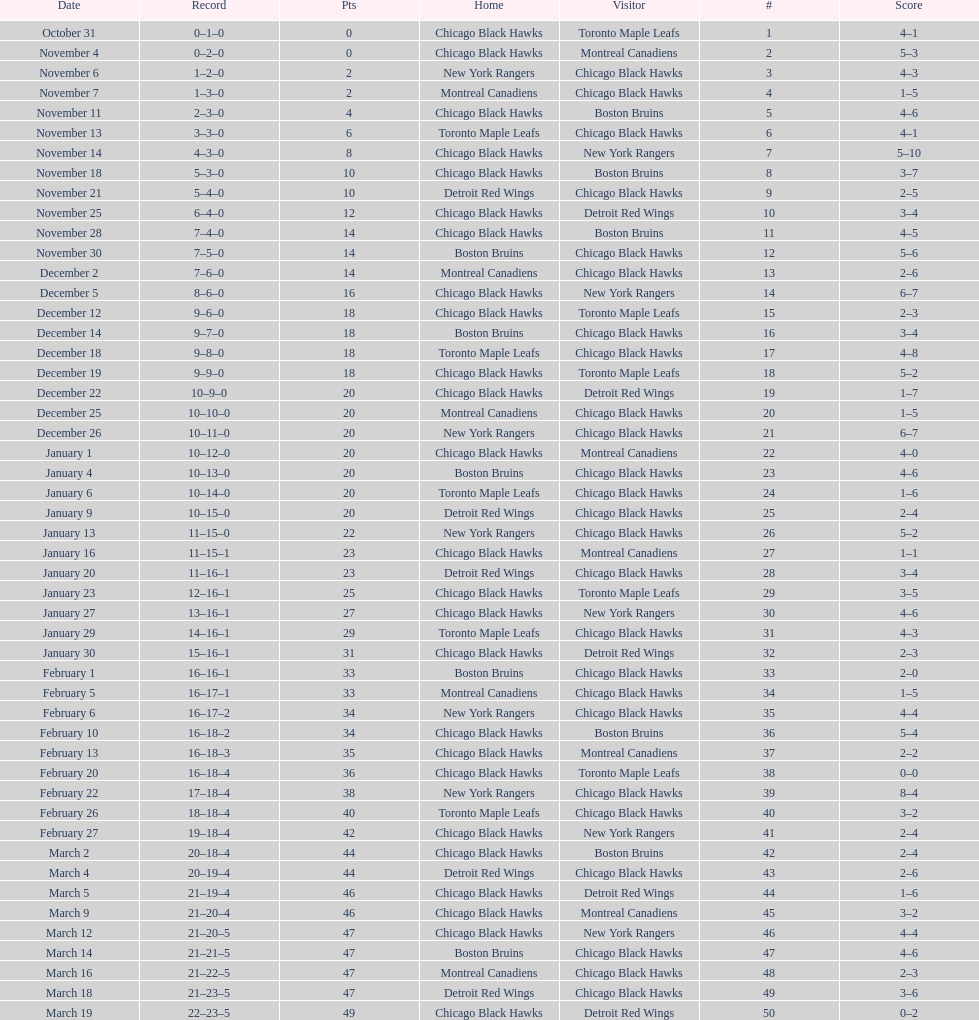How long is the duration of one season (from the first game to the last)? 5 months. Would you mind parsing the complete table? {'header': ['Date', 'Record', 'Pts', 'Home', 'Visitor', '#', 'Score'], 'rows': [['October 31', '0–1–0', '0', 'Chicago Black Hawks', 'Toronto Maple Leafs', '1', '4–1'], ['November 4', '0–2–0', '0', 'Chicago Black Hawks', 'Montreal Canadiens', '2', '5–3'], ['November 6', '1–2–0', '2', 'New York Rangers', 'Chicago Black Hawks', '3', '4–3'], ['November 7', '1–3–0', '2', 'Montreal Canadiens', 'Chicago Black Hawks', '4', '1–5'], ['November 11', '2–3–0', '4', 'Chicago Black Hawks', 'Boston Bruins', '5', '4–6'], ['November 13', '3–3–0', '6', 'Toronto Maple Leafs', 'Chicago Black Hawks', '6', '4–1'], ['November 14', '4–3–0', '8', 'Chicago Black Hawks', 'New York Rangers', '7', '5–10'], ['November 18', '5–3–0', '10', 'Chicago Black Hawks', 'Boston Bruins', '8', '3–7'], ['November 21', '5–4–0', '10', 'Detroit Red Wings', 'Chicago Black Hawks', '9', '2–5'], ['November 25', '6–4–0', '12', 'Chicago Black Hawks', 'Detroit Red Wings', '10', '3–4'], ['November 28', '7–4–0', '14', 'Chicago Black Hawks', 'Boston Bruins', '11', '4–5'], ['November 30', '7–5–0', '14', 'Boston Bruins', 'Chicago Black Hawks', '12', '5–6'], ['December 2', '7–6–0', '14', 'Montreal Canadiens', 'Chicago Black Hawks', '13', '2–6'], ['December 5', '8–6–0', '16', 'Chicago Black Hawks', 'New York Rangers', '14', '6–7'], ['December 12', '9–6–0', '18', 'Chicago Black Hawks', 'Toronto Maple Leafs', '15', '2–3'], ['December 14', '9–7–0', '18', 'Boston Bruins', 'Chicago Black Hawks', '16', '3–4'], ['December 18', '9–8–0', '18', 'Toronto Maple Leafs', 'Chicago Black Hawks', '17', '4–8'], ['December 19', '9–9–0', '18', 'Chicago Black Hawks', 'Toronto Maple Leafs', '18', '5–2'], ['December 22', '10–9–0', '20', 'Chicago Black Hawks', 'Detroit Red Wings', '19', '1–7'], ['December 25', '10–10–0', '20', 'Montreal Canadiens', 'Chicago Black Hawks', '20', '1–5'], ['December 26', '10–11–0', '20', 'New York Rangers', 'Chicago Black Hawks', '21', '6–7'], ['January 1', '10–12–0', '20', 'Chicago Black Hawks', 'Montreal Canadiens', '22', '4–0'], ['January 4', '10–13–0', '20', 'Boston Bruins', 'Chicago Black Hawks', '23', '4–6'], ['January 6', '10–14–0', '20', 'Toronto Maple Leafs', 'Chicago Black Hawks', '24', '1–6'], ['January 9', '10–15–0', '20', 'Detroit Red Wings', 'Chicago Black Hawks', '25', '2–4'], ['January 13', '11–15–0', '22', 'New York Rangers', 'Chicago Black Hawks', '26', '5–2'], ['January 16', '11–15–1', '23', 'Chicago Black Hawks', 'Montreal Canadiens', '27', '1–1'], ['January 20', '11–16–1', '23', 'Detroit Red Wings', 'Chicago Black Hawks', '28', '3–4'], ['January 23', '12–16–1', '25', 'Chicago Black Hawks', 'Toronto Maple Leafs', '29', '3–5'], ['January 27', '13–16–1', '27', 'Chicago Black Hawks', 'New York Rangers', '30', '4–6'], ['January 29', '14–16–1', '29', 'Toronto Maple Leafs', 'Chicago Black Hawks', '31', '4–3'], ['January 30', '15–16–1', '31', 'Chicago Black Hawks', 'Detroit Red Wings', '32', '2–3'], ['February 1', '16–16–1', '33', 'Boston Bruins', 'Chicago Black Hawks', '33', '2–0'], ['February 5', '16–17–1', '33', 'Montreal Canadiens', 'Chicago Black Hawks', '34', '1–5'], ['February 6', '16–17–2', '34', 'New York Rangers', 'Chicago Black Hawks', '35', '4–4'], ['February 10', '16–18–2', '34', 'Chicago Black Hawks', 'Boston Bruins', '36', '5–4'], ['February 13', '16–18–3', '35', 'Chicago Black Hawks', 'Montreal Canadiens', '37', '2–2'], ['February 20', '16–18–4', '36', 'Chicago Black Hawks', 'Toronto Maple Leafs', '38', '0–0'], ['February 22', '17–18–4', '38', 'New York Rangers', 'Chicago Black Hawks', '39', '8–4'], ['February 26', '18–18–4', '40', 'Toronto Maple Leafs', 'Chicago Black Hawks', '40', '3–2'], ['February 27', '19–18–4', '42', 'Chicago Black Hawks', 'New York Rangers', '41', '2–4'], ['March 2', '20–18–4', '44', 'Chicago Black Hawks', 'Boston Bruins', '42', '2–4'], ['March 4', '20–19–4', '44', 'Detroit Red Wings', 'Chicago Black Hawks', '43', '2–6'], ['March 5', '21–19–4', '46', 'Chicago Black Hawks', 'Detroit Red Wings', '44', '1–6'], ['March 9', '21–20–4', '46', 'Chicago Black Hawks', 'Montreal Canadiens', '45', '3–2'], ['March 12', '21–20–5', '47', 'Chicago Black Hawks', 'New York Rangers', '46', '4–4'], ['March 14', '21–21–5', '47', 'Boston Bruins', 'Chicago Black Hawks', '47', '4–6'], ['March 16', '21–22–5', '47', 'Montreal Canadiens', 'Chicago Black Hawks', '48', '2–3'], ['March 18', '21–23–5', '47', 'Detroit Red Wings', 'Chicago Black Hawks', '49', '3–6'], ['March 19', '22–23–5', '49', 'Chicago Black Hawks', 'Detroit Red Wings', '50', '0–2']]} 